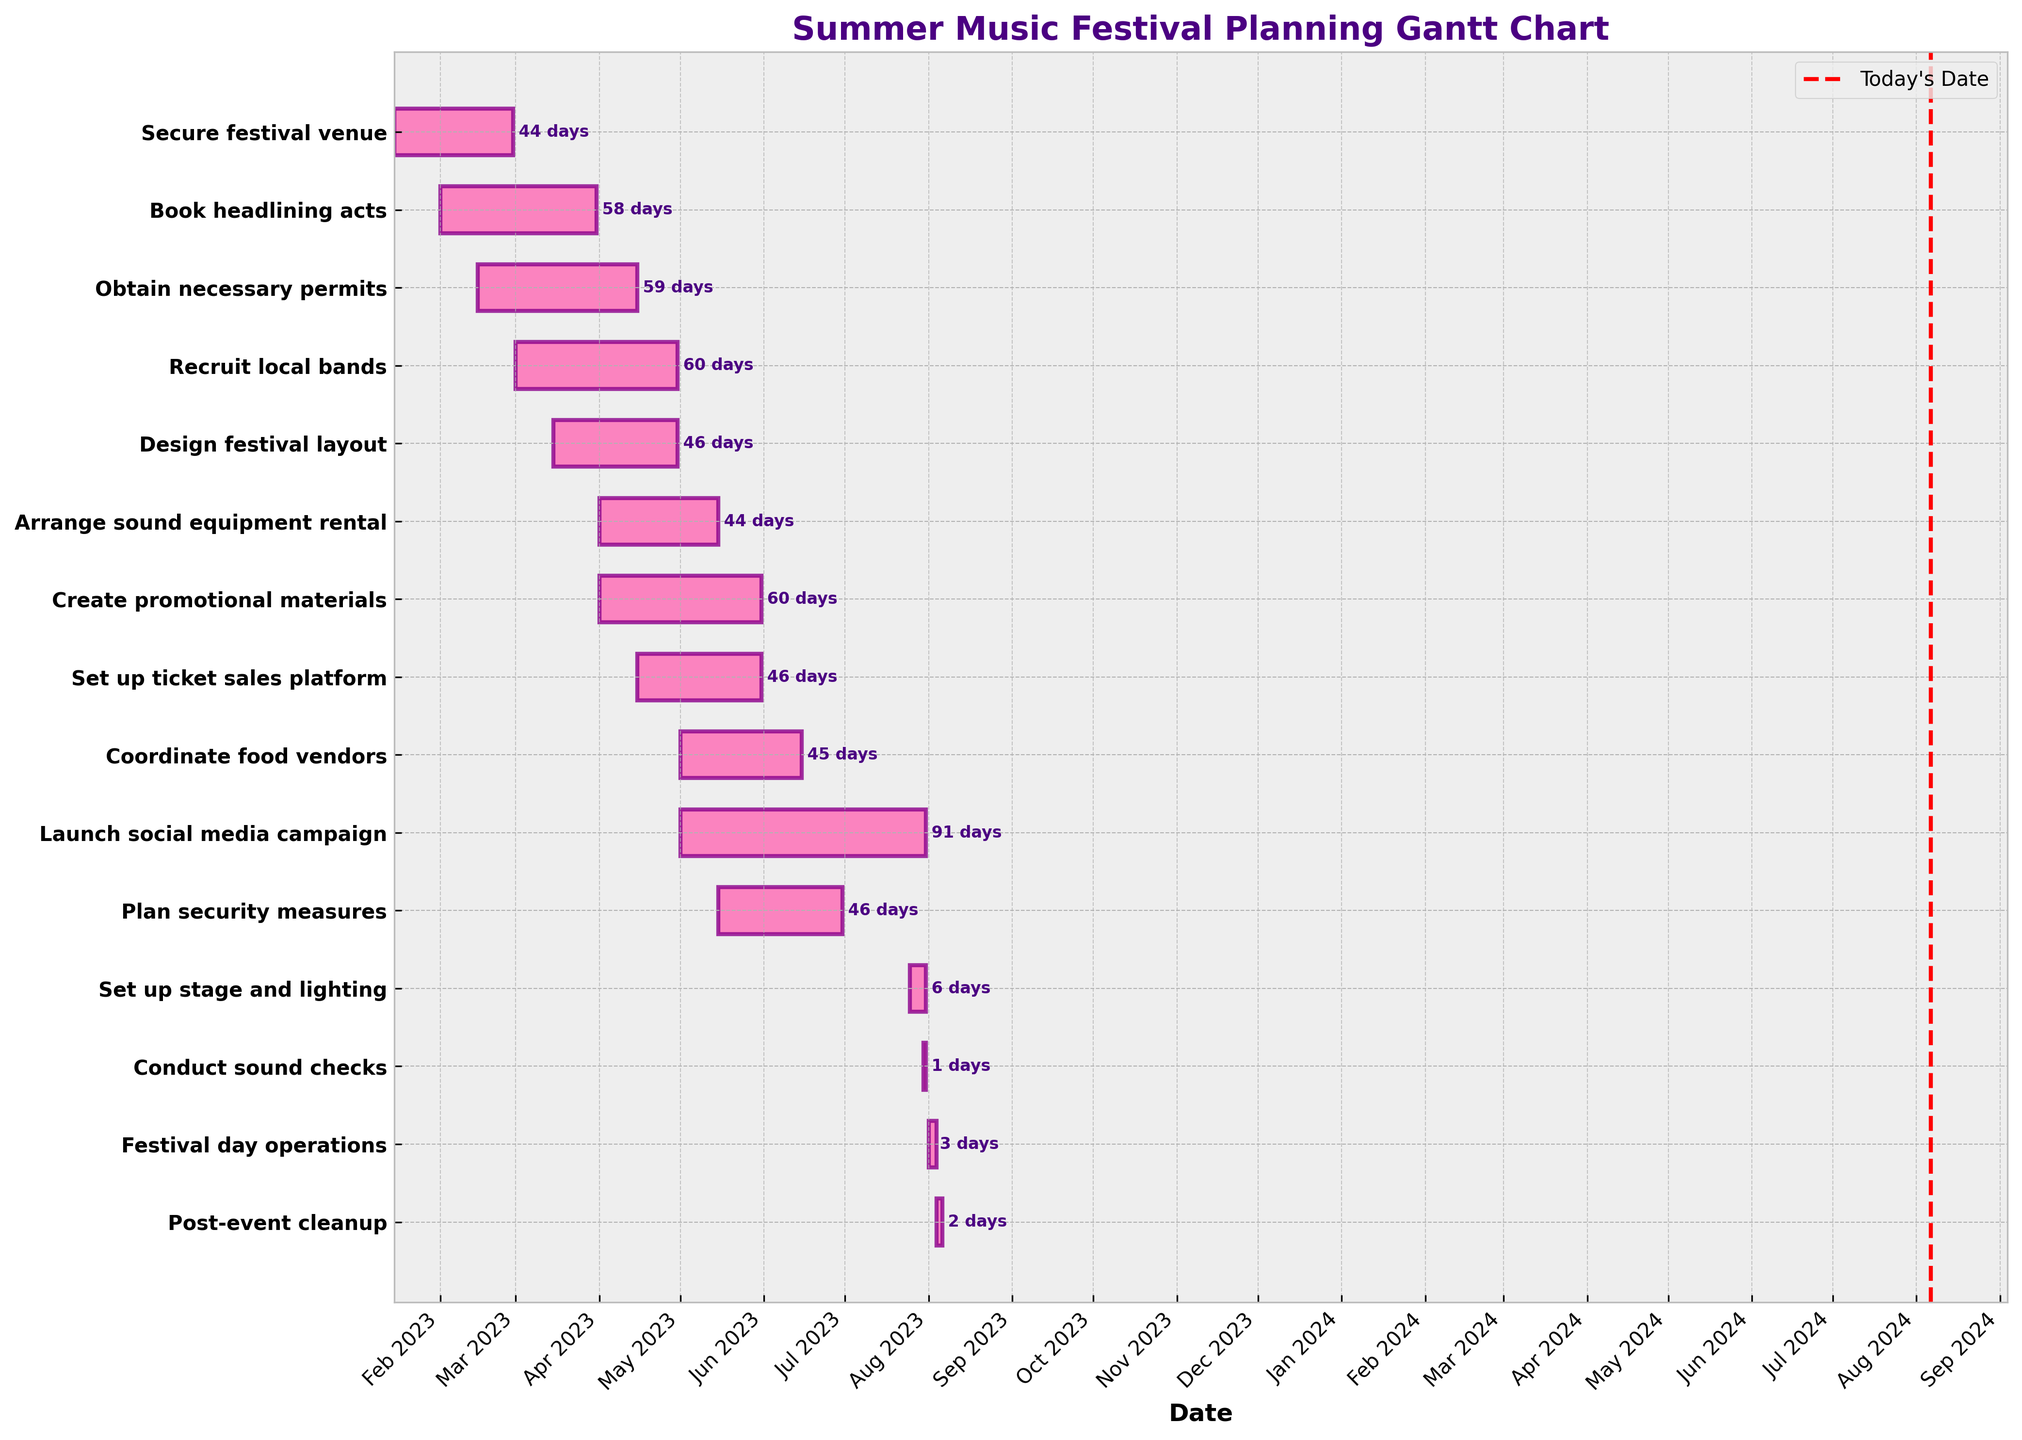Which task is scheduled to end the latest? By looking at the end dates on the Gantt chart, the task "Launch social media campaign" ends the latest on July 31, 2023.
Answer: Launch social media campaign How long is the duration of the "Recruit local bands" task? By checking the start and end dates on the Gantt chart, "Recruit local bands" starts on March 1, 2023, and ends on April 30, 2023, lasting 60 days.
Answer: 60 days Which task has the shortest duration, and how many days is it? By comparing the durations of all tasks on the Gantt chart, "Conduct sound checks" has the shortest duration of 1 day.
Answer: Conduct sound checks, 1 day When is the "Set up stage and lighting" task scheduled to start? Referring to the start date on the Gantt chart, "Set up stage and lighting" is scheduled to start on July 25, 2023.
Answer: July 25, 2023 Which tasks overlap entirely in the month of April? By examining the timeline of tasks on the Gantt chart, the tasks "Recruit local bands", "Design festival layout", and "Obtain necessary permits" all overlap entirely in April.
Answer: Recruit local bands, Design festival layout, Obtain necessary permits How many tasks are scheduled to start in the month of May? Counting the number of task bars starting in May on the Gantt chart, the tasks "Coordinate food vendors", "Plan security measures", and "Launch social media campaign" start in May.
Answer: 3 tasks Which task spans both June and July? By observing the task bars on the Gantt chart, the task "Launch social media campaign" spans both June and July.
Answer: Launch social media campaign What is the combined total duration of the tasks ending in May? Summing up the durations from the task bars ending in May on the Gantt chart ("Arrange sound equipment rental", "Create promotional materials", and "Set up ticket sales platform"): 44 days + 60 days + 46 days = 150 days.
Answer: 150 days Which two tasks have the same duration but different timelines? By comparing durations and timelines on the Gantt chart, "Design festival layout" and "Plan security measures" each last 46 days, but occur at different times.
Answer: Design festival layout and Plan security measures How many days before "Festival day operations" is "Post-event cleanup" scheduled? Checking the end date of "Festival day operations" and the start date of "Post-event cleanup" on the Gantt chart, "Festival day operations" ends on August 3, 2023, and "Post-event cleanup" starts on August 4, 2023, which is the next day, so 1 day before.
Answer: 1 day 